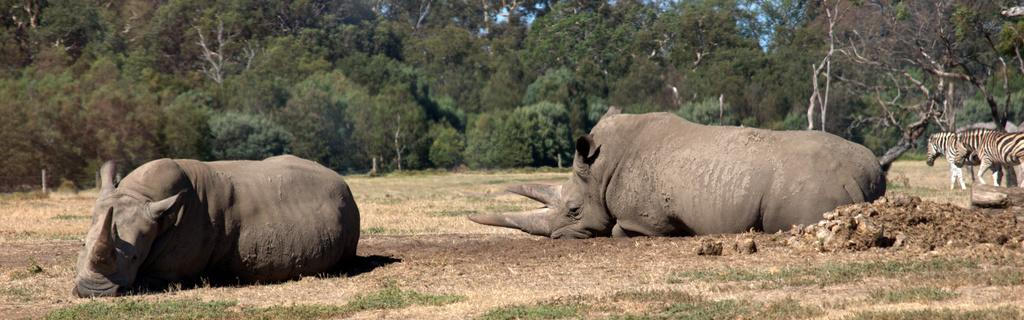What animal is located in the middle of the image? There is a rhinoceros in the middle of the image. What other animals can be seen in the image? There are zebras on the right side of the image. What type of vegetation is visible at the top of the image? There are trees at the top of the image. What type of ground cover is visible at the bottom of the image? There is grass at the bottom of the image. What type of engine can be seen in the image? There is no engine present in the image; it features a rhinoceros, zebras, trees, and grass. Can you tell me how many ducks are visible in the image? There are no ducks present in the image. 